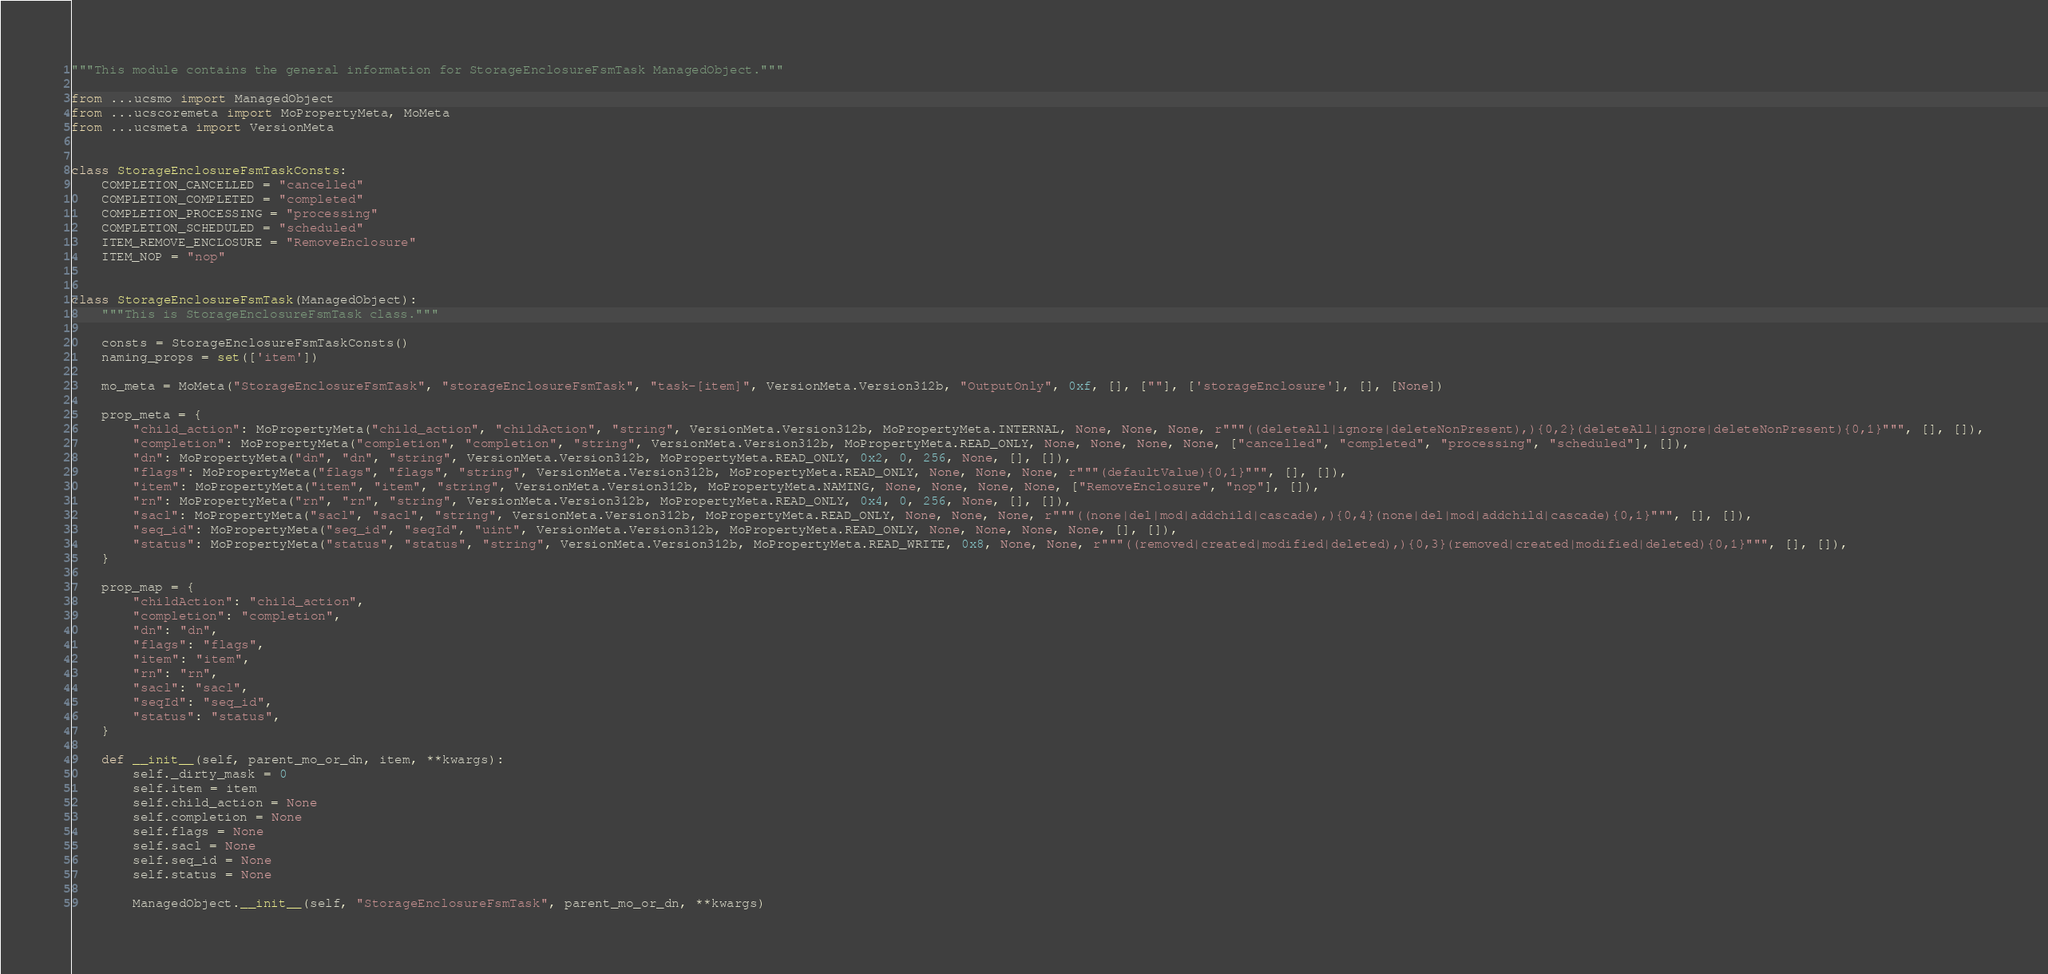<code> <loc_0><loc_0><loc_500><loc_500><_Python_>"""This module contains the general information for StorageEnclosureFsmTask ManagedObject."""

from ...ucsmo import ManagedObject
from ...ucscoremeta import MoPropertyMeta, MoMeta
from ...ucsmeta import VersionMeta


class StorageEnclosureFsmTaskConsts:
    COMPLETION_CANCELLED = "cancelled"
    COMPLETION_COMPLETED = "completed"
    COMPLETION_PROCESSING = "processing"
    COMPLETION_SCHEDULED = "scheduled"
    ITEM_REMOVE_ENCLOSURE = "RemoveEnclosure"
    ITEM_NOP = "nop"


class StorageEnclosureFsmTask(ManagedObject):
    """This is StorageEnclosureFsmTask class."""

    consts = StorageEnclosureFsmTaskConsts()
    naming_props = set(['item'])

    mo_meta = MoMeta("StorageEnclosureFsmTask", "storageEnclosureFsmTask", "task-[item]", VersionMeta.Version312b, "OutputOnly", 0xf, [], [""], ['storageEnclosure'], [], [None])

    prop_meta = {
        "child_action": MoPropertyMeta("child_action", "childAction", "string", VersionMeta.Version312b, MoPropertyMeta.INTERNAL, None, None, None, r"""((deleteAll|ignore|deleteNonPresent),){0,2}(deleteAll|ignore|deleteNonPresent){0,1}""", [], []),
        "completion": MoPropertyMeta("completion", "completion", "string", VersionMeta.Version312b, MoPropertyMeta.READ_ONLY, None, None, None, None, ["cancelled", "completed", "processing", "scheduled"], []),
        "dn": MoPropertyMeta("dn", "dn", "string", VersionMeta.Version312b, MoPropertyMeta.READ_ONLY, 0x2, 0, 256, None, [], []),
        "flags": MoPropertyMeta("flags", "flags", "string", VersionMeta.Version312b, MoPropertyMeta.READ_ONLY, None, None, None, r"""(defaultValue){0,1}""", [], []),
        "item": MoPropertyMeta("item", "item", "string", VersionMeta.Version312b, MoPropertyMeta.NAMING, None, None, None, None, ["RemoveEnclosure", "nop"], []),
        "rn": MoPropertyMeta("rn", "rn", "string", VersionMeta.Version312b, MoPropertyMeta.READ_ONLY, 0x4, 0, 256, None, [], []),
        "sacl": MoPropertyMeta("sacl", "sacl", "string", VersionMeta.Version312b, MoPropertyMeta.READ_ONLY, None, None, None, r"""((none|del|mod|addchild|cascade),){0,4}(none|del|mod|addchild|cascade){0,1}""", [], []),
        "seq_id": MoPropertyMeta("seq_id", "seqId", "uint", VersionMeta.Version312b, MoPropertyMeta.READ_ONLY, None, None, None, None, [], []),
        "status": MoPropertyMeta("status", "status", "string", VersionMeta.Version312b, MoPropertyMeta.READ_WRITE, 0x8, None, None, r"""((removed|created|modified|deleted),){0,3}(removed|created|modified|deleted){0,1}""", [], []),
    }

    prop_map = {
        "childAction": "child_action", 
        "completion": "completion", 
        "dn": "dn", 
        "flags": "flags", 
        "item": "item", 
        "rn": "rn", 
        "sacl": "sacl", 
        "seqId": "seq_id", 
        "status": "status", 
    }

    def __init__(self, parent_mo_or_dn, item, **kwargs):
        self._dirty_mask = 0
        self.item = item
        self.child_action = None
        self.completion = None
        self.flags = None
        self.sacl = None
        self.seq_id = None
        self.status = None

        ManagedObject.__init__(self, "StorageEnclosureFsmTask", parent_mo_or_dn, **kwargs)
</code> 